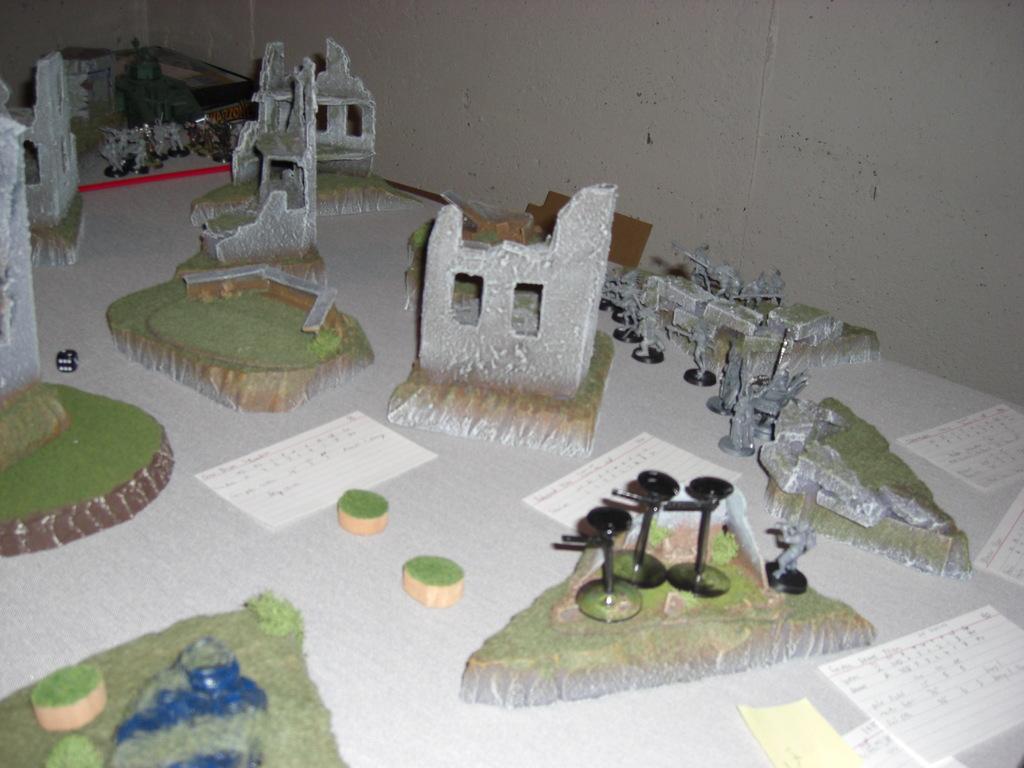Please provide a concise description of this image. This is the picture of a miniature. In this image there are artificial buildings, roads and there is grass. At the back there's a wall. 